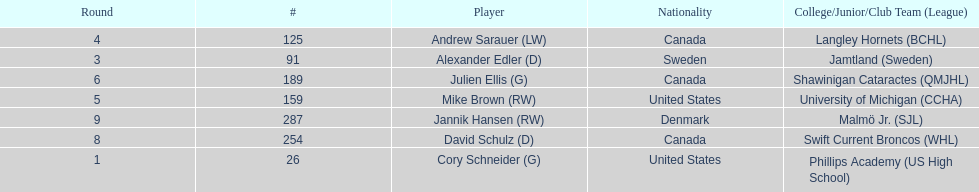Who is the only player to have denmark listed as their nationality? Jannik Hansen (RW). 